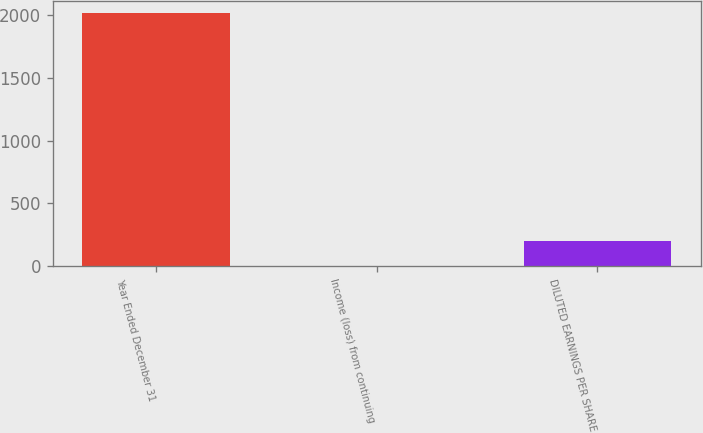Convert chart to OTSL. <chart><loc_0><loc_0><loc_500><loc_500><bar_chart><fcel>Year Ended December 31<fcel>Income (loss) from continuing<fcel>DILUTED EARNINGS PER SHARE<nl><fcel>2016<fcel>0.04<fcel>201.64<nl></chart> 